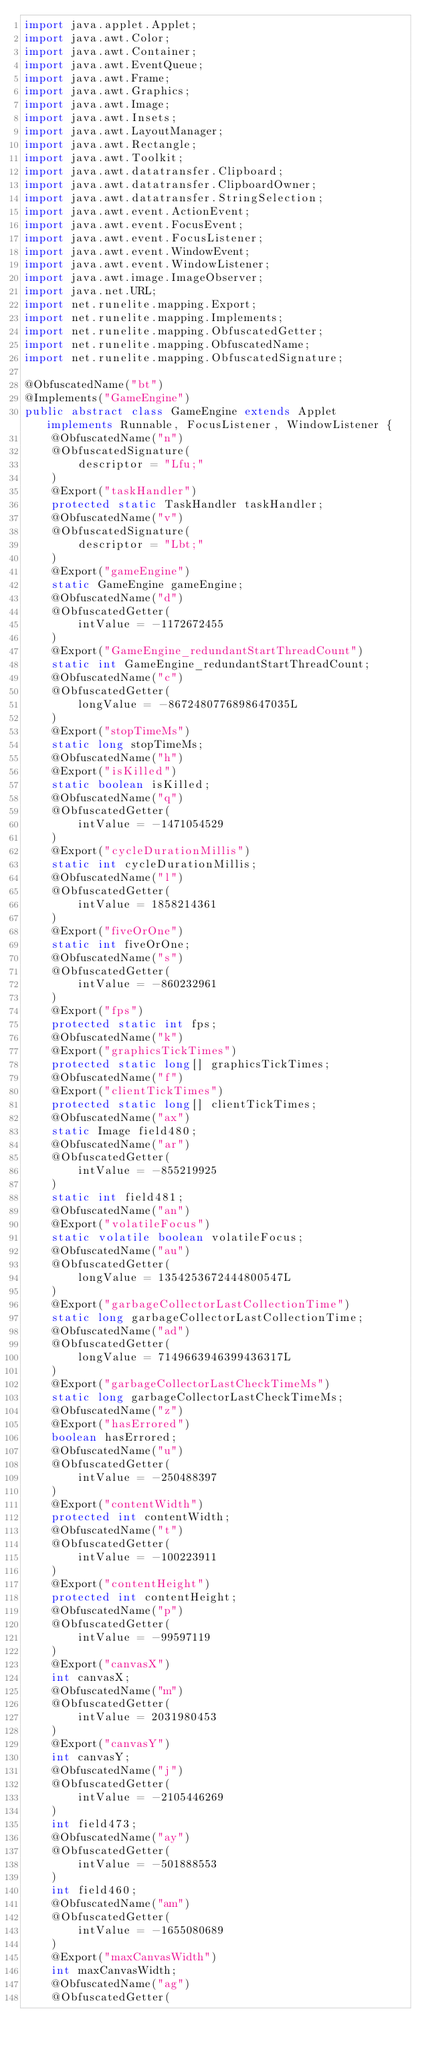<code> <loc_0><loc_0><loc_500><loc_500><_Java_>import java.applet.Applet;
import java.awt.Color;
import java.awt.Container;
import java.awt.EventQueue;
import java.awt.Frame;
import java.awt.Graphics;
import java.awt.Image;
import java.awt.Insets;
import java.awt.LayoutManager;
import java.awt.Rectangle;
import java.awt.Toolkit;
import java.awt.datatransfer.Clipboard;
import java.awt.datatransfer.ClipboardOwner;
import java.awt.datatransfer.StringSelection;
import java.awt.event.ActionEvent;
import java.awt.event.FocusEvent;
import java.awt.event.FocusListener;
import java.awt.event.WindowEvent;
import java.awt.event.WindowListener;
import java.awt.image.ImageObserver;
import java.net.URL;
import net.runelite.mapping.Export;
import net.runelite.mapping.Implements;
import net.runelite.mapping.ObfuscatedGetter;
import net.runelite.mapping.ObfuscatedName;
import net.runelite.mapping.ObfuscatedSignature;

@ObfuscatedName("bt")
@Implements("GameEngine")
public abstract class GameEngine extends Applet implements Runnable, FocusListener, WindowListener {
	@ObfuscatedName("n")
	@ObfuscatedSignature(
		descriptor = "Lfu;"
	)
	@Export("taskHandler")
	protected static TaskHandler taskHandler;
	@ObfuscatedName("v")
	@ObfuscatedSignature(
		descriptor = "Lbt;"
	)
	@Export("gameEngine")
	static GameEngine gameEngine;
	@ObfuscatedName("d")
	@ObfuscatedGetter(
		intValue = -1172672455
	)
	@Export("GameEngine_redundantStartThreadCount")
	static int GameEngine_redundantStartThreadCount;
	@ObfuscatedName("c")
	@ObfuscatedGetter(
		longValue = -8672480776898647035L
	)
	@Export("stopTimeMs")
	static long stopTimeMs;
	@ObfuscatedName("h")
	@Export("isKilled")
	static boolean isKilled;
	@ObfuscatedName("q")
	@ObfuscatedGetter(
		intValue = -1471054529
	)
	@Export("cycleDurationMillis")
	static int cycleDurationMillis;
	@ObfuscatedName("l")
	@ObfuscatedGetter(
		intValue = 1858214361
	)
	@Export("fiveOrOne")
	static int fiveOrOne;
	@ObfuscatedName("s")
	@ObfuscatedGetter(
		intValue = -860232961
	)
	@Export("fps")
	protected static int fps;
	@ObfuscatedName("k")
	@Export("graphicsTickTimes")
	protected static long[] graphicsTickTimes;
	@ObfuscatedName("f")
	@Export("clientTickTimes")
	protected static long[] clientTickTimes;
	@ObfuscatedName("ax")
	static Image field480;
	@ObfuscatedName("ar")
	@ObfuscatedGetter(
		intValue = -855219925
	)
	static int field481;
	@ObfuscatedName("an")
	@Export("volatileFocus")
	static volatile boolean volatileFocus;
	@ObfuscatedName("au")
	@ObfuscatedGetter(
		longValue = 1354253672444800547L
	)
	@Export("garbageCollectorLastCollectionTime")
	static long garbageCollectorLastCollectionTime;
	@ObfuscatedName("ad")
	@ObfuscatedGetter(
		longValue = 7149663946399436317L
	)
	@Export("garbageCollectorLastCheckTimeMs")
	static long garbageCollectorLastCheckTimeMs;
	@ObfuscatedName("z")
	@Export("hasErrored")
	boolean hasErrored;
	@ObfuscatedName("u")
	@ObfuscatedGetter(
		intValue = -250488397
	)
	@Export("contentWidth")
	protected int contentWidth;
	@ObfuscatedName("t")
	@ObfuscatedGetter(
		intValue = -100223911
	)
	@Export("contentHeight")
	protected int contentHeight;
	@ObfuscatedName("p")
	@ObfuscatedGetter(
		intValue = -99597119
	)
	@Export("canvasX")
	int canvasX;
	@ObfuscatedName("m")
	@ObfuscatedGetter(
		intValue = 2031980453
	)
	@Export("canvasY")
	int canvasY;
	@ObfuscatedName("j")
	@ObfuscatedGetter(
		intValue = -2105446269
	)
	int field473;
	@ObfuscatedName("ay")
	@ObfuscatedGetter(
		intValue = -501888553
	)
	int field460;
	@ObfuscatedName("am")
	@ObfuscatedGetter(
		intValue = -1655080689
	)
	@Export("maxCanvasWidth")
	int maxCanvasWidth;
	@ObfuscatedName("ag")
	@ObfuscatedGetter(</code> 